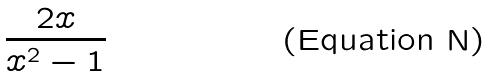<formula> <loc_0><loc_0><loc_500><loc_500>\frac { 2 x } { x ^ { 2 } - 1 }</formula> 